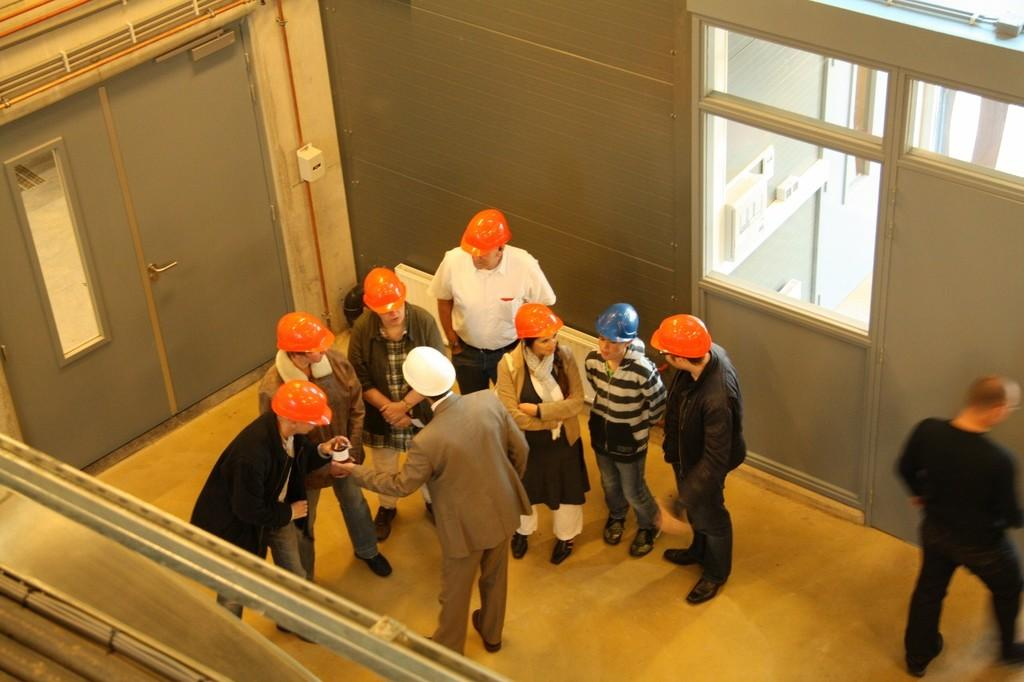What can be observed about the people in the image? There are persons standing in the image, and all of them are wearing helmets. What is located on the left side of the image? There is a door on the left side of the image. Can you describe the position of the person on the right side of the image? There is a person standing on the right side of the image. What type of cream can be seen being spread on the yard in the image? There is no cream or yard present in the image; it features persons wearing helmets and a door. Can you describe the romantic interaction between the persons in the image? There is no romantic interaction or kissing depicted in the image; the persons are simply standing and wearing helmets. 